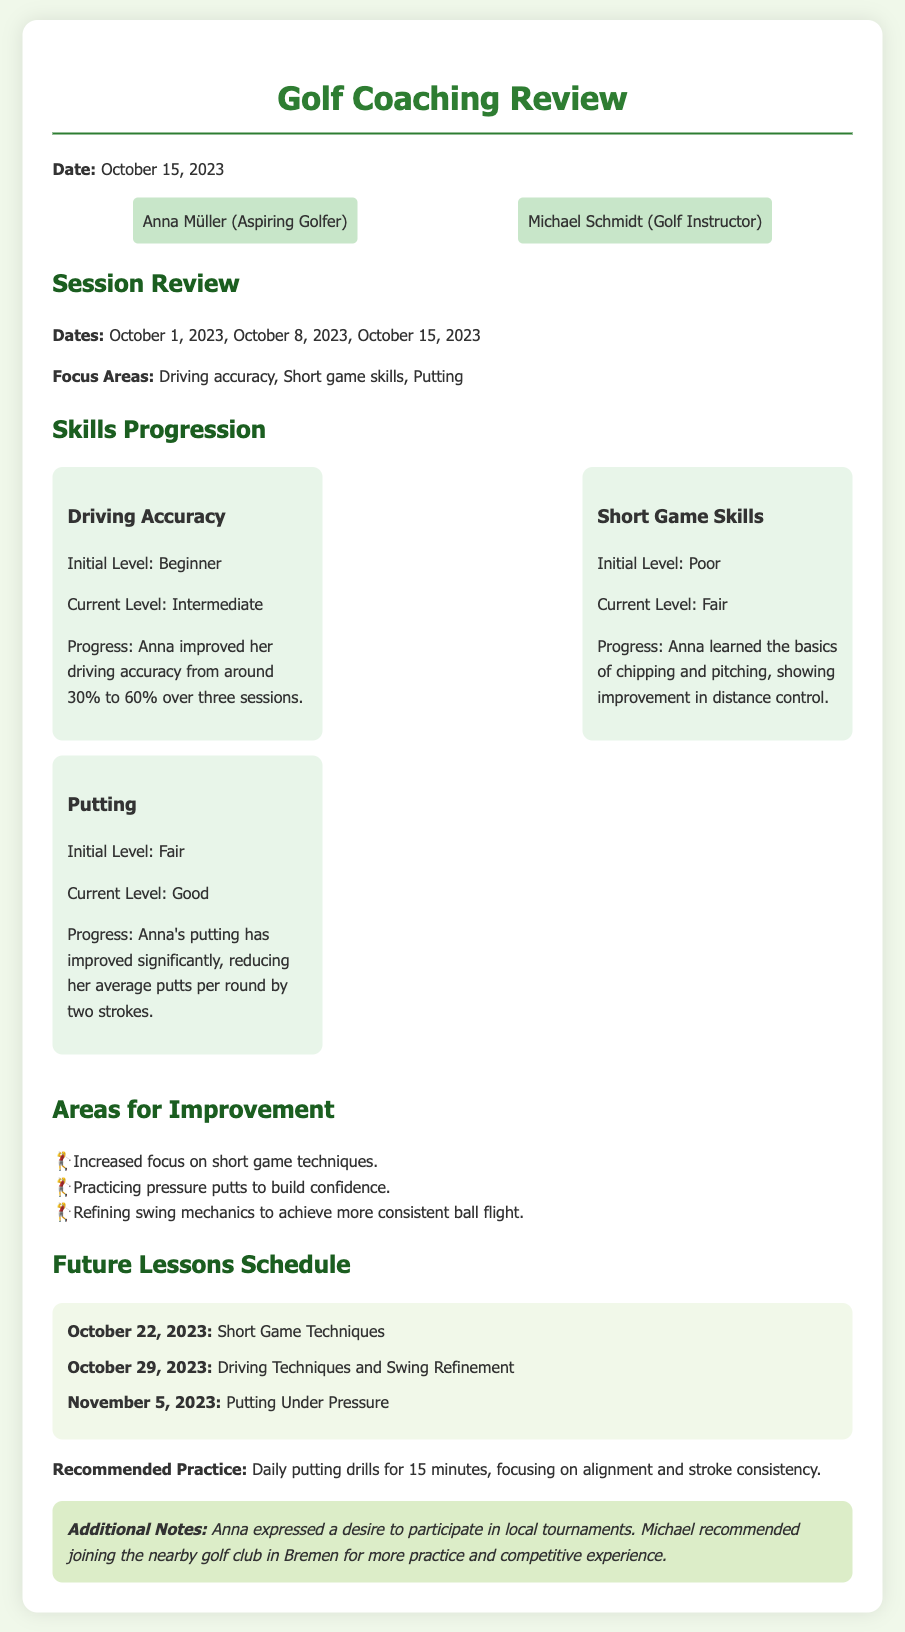What date was the review conducted? The review was conducted on October 15, 2023, as mentioned in the document.
Answer: October 15, 2023 Who is the golf instructor? The document lists Michael Schmidt as the golf instructor.
Answer: Michael Schmidt What was Anna's initial level in Driving Accuracy? The initial level for Driving Accuracy is specified as Beginner.
Answer: Beginner How much did Anna improve her Driving Accuracy? The document states that Anna improved her driving accuracy from around 30% to 60%.
Answer: 30% to 60% What is the focus area for the lesson on October 22, 2023? The lesson scheduled for October 22, 2023, focuses on Short Game Techniques.
Answer: Short Game Techniques What is an area identified for improvement? One identified area for improvement is increasing focus on short game techniques.
Answer: Increased focus on short game techniques How many future lessons are scheduled? The document lists three future lessons scheduled.
Answer: Three What did Anna express a desire for in the additional notes? In the additional notes, Anna expressed a desire to participate in local tournaments.
Answer: Participate in local tournaments What practice is recommended related to putting? The document recommends daily putting drills for 15 minutes.
Answer: Daily putting drills for 15 minutes 